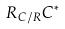Convert formula to latex. <formula><loc_0><loc_0><loc_500><loc_500>R _ { C / R } C ^ { * }</formula> 